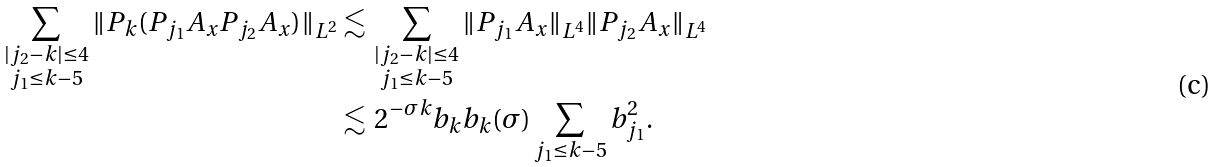Convert formula to latex. <formula><loc_0><loc_0><loc_500><loc_500>\sum _ { \substack { | j _ { 2 } - k | \leq 4 \\ j _ { 1 } \leq k - 5 } } \| P _ { k } ( P _ { j _ { 1 } } A _ { x } P _ { j _ { 2 } } A _ { x } ) \| _ { L ^ { 2 } } & \lesssim \, \sum _ { \substack { | j _ { 2 } - k | \leq 4 \\ j _ { 1 } \leq k - 5 } } \| P _ { j _ { 1 } } A _ { x } \| _ { L ^ { 4 } } \| P _ { j _ { 2 } } A _ { x } \| _ { L ^ { 4 } } \\ & \lesssim \, 2 ^ { - \sigma k } b _ { k } b _ { k } ( \sigma ) \sum _ { j _ { 1 } \leq k - 5 } b _ { j _ { 1 } } ^ { 2 } .</formula> 